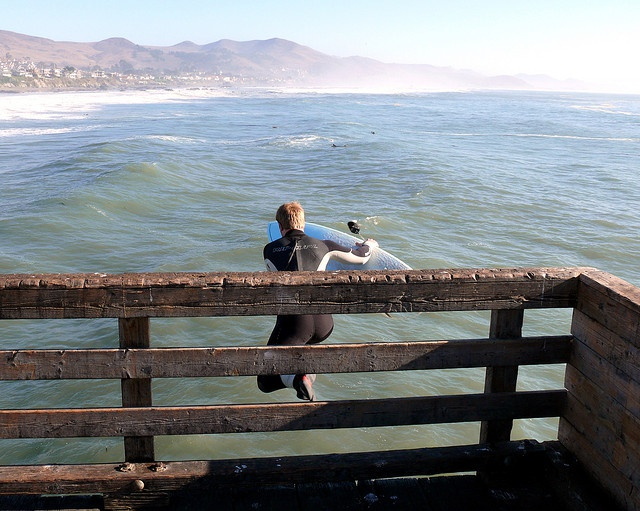Describe the objects in this image and their specific colors. I can see people in lightblue, black, gray, and ivory tones and surfboard in lightblue, darkgray, and lightgray tones in this image. 